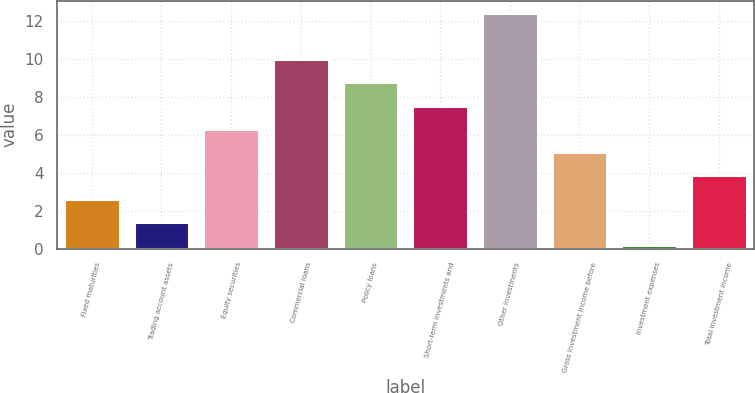Convert chart to OTSL. <chart><loc_0><loc_0><loc_500><loc_500><bar_chart><fcel>Fixed maturities<fcel>Trading account assets<fcel>Equity securities<fcel>Commercial loans<fcel>Policy loans<fcel>Short-term investments and<fcel>Other investments<fcel>Gross investment income before<fcel>Investment expenses<fcel>Total investment income<nl><fcel>2.63<fcel>1.41<fcel>6.3<fcel>9.98<fcel>8.76<fcel>7.53<fcel>12.43<fcel>5.08<fcel>0.18<fcel>3.85<nl></chart> 